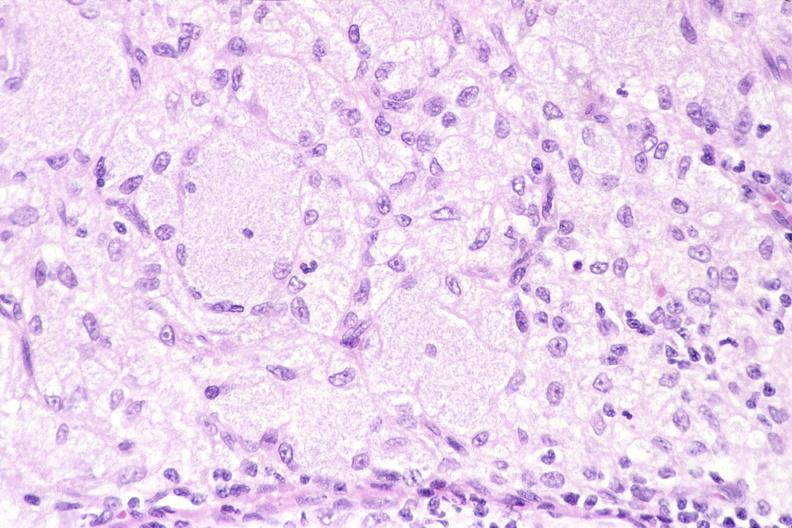what does this image show?
Answer the question using a single word or phrase. Lymph node 